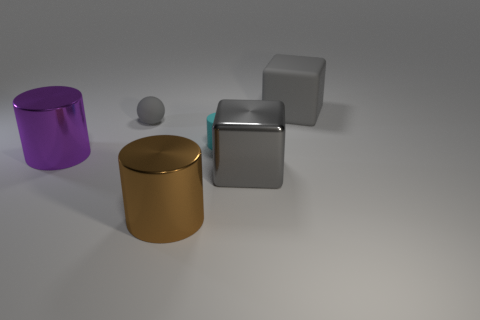What number of cylinders are either big brown things or large gray shiny objects?
Your response must be concise. 1. Is the material of the small gray thing the same as the big purple thing?
Make the answer very short. No. The cyan rubber thing that is the same shape as the big brown object is what size?
Make the answer very short. Small. What is the material of the gray object that is on the right side of the tiny gray sphere and behind the tiny cylinder?
Provide a succinct answer. Rubber. Are there an equal number of big rubber objects that are to the left of the matte ball and metal objects?
Keep it short and to the point. No. How many objects are either big gray cubes behind the big shiny block or small cyan rubber cylinders?
Keep it short and to the point. 2. There is a large shiny object that is to the left of the big brown metal cylinder; is its color the same as the tiny cylinder?
Your answer should be very brief. No. What size is the gray block that is in front of the big matte block?
Keep it short and to the point. Large. What is the shape of the large gray object on the left side of the big thing behind the tiny matte cylinder?
Your response must be concise. Cube. The tiny rubber object that is the same shape as the big purple metal thing is what color?
Your answer should be compact. Cyan. 